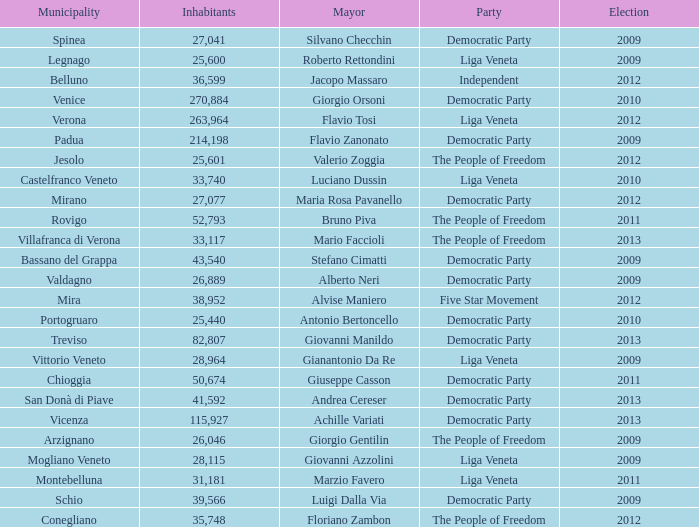In the election earlier than 2012 how many Inhabitants had a Party of five star movement? None. 